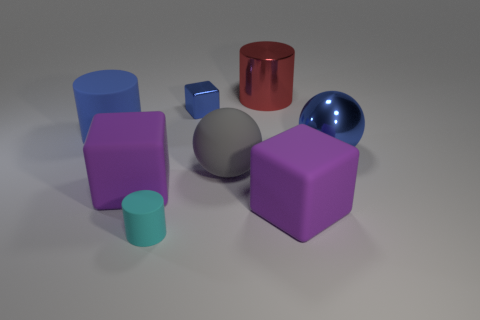Add 2 objects. How many objects exist? 10 Subtract all blocks. How many objects are left? 5 Subtract 1 cyan cylinders. How many objects are left? 7 Subtract all large red cylinders. Subtract all big rubber cubes. How many objects are left? 5 Add 6 cyan rubber cylinders. How many cyan rubber cylinders are left? 7 Add 4 purple objects. How many purple objects exist? 6 